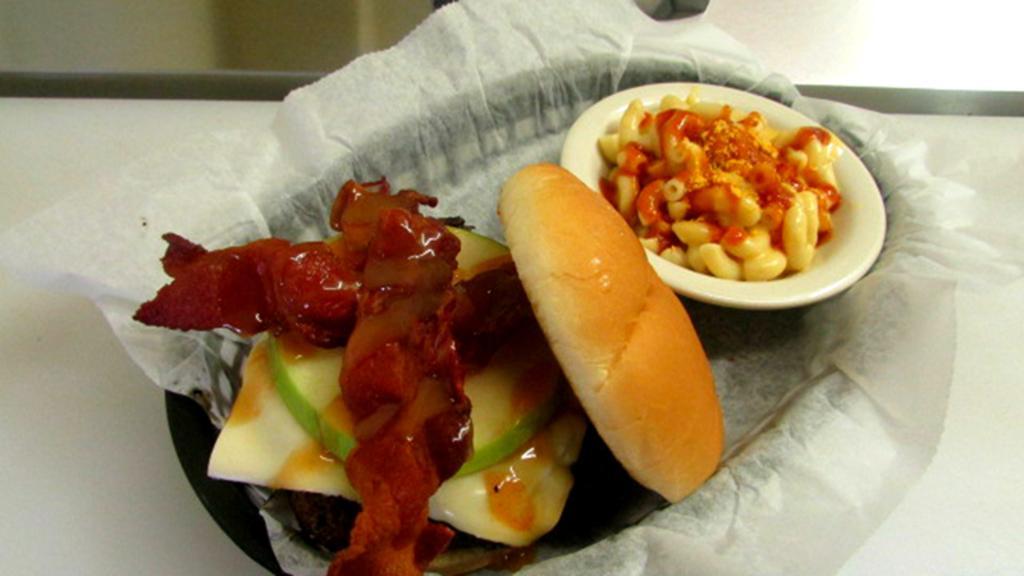How would you summarize this image in a sentence or two? In the center of the image there is a plate, tissue, burger, bowl, pasta and a gravy placed on the table. 